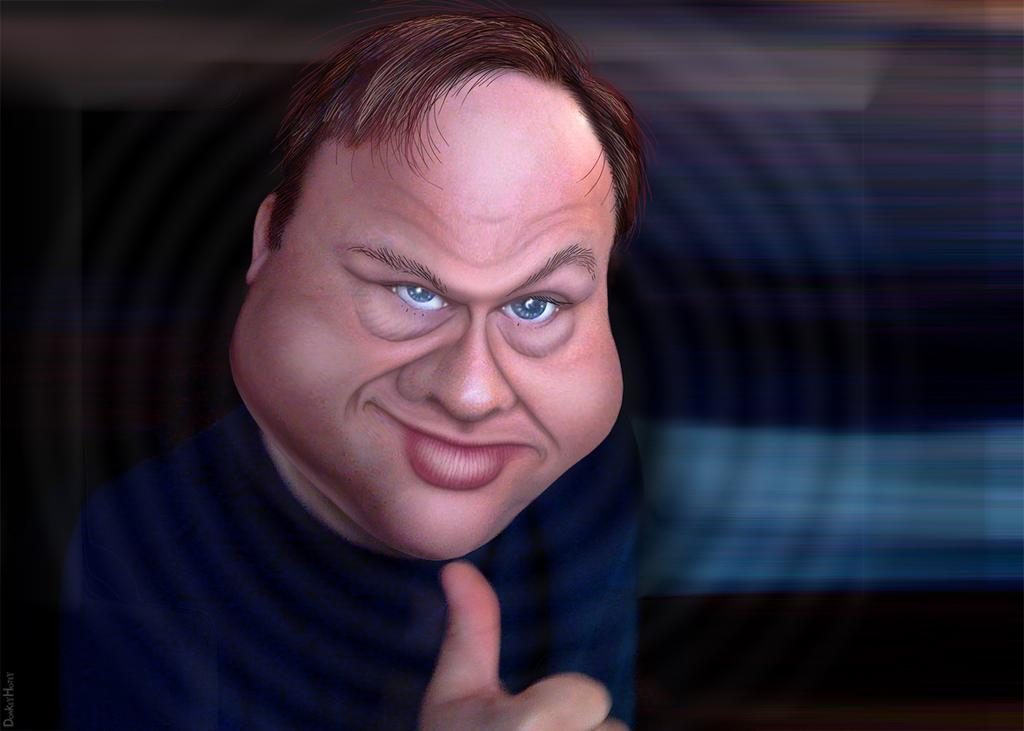What is the main subject in the foreground of the image? There is an animated image of a person in the foreground of the image. How is the background of the image depicted? The background of the image is blurred. Where can some text be found in the image? There is some text on the left side of the image. Can you tell me how many flies are buzzing around the animated person in the image? There are no flies present in the image; it features an animated person with a blurred background and some text on the left side. 